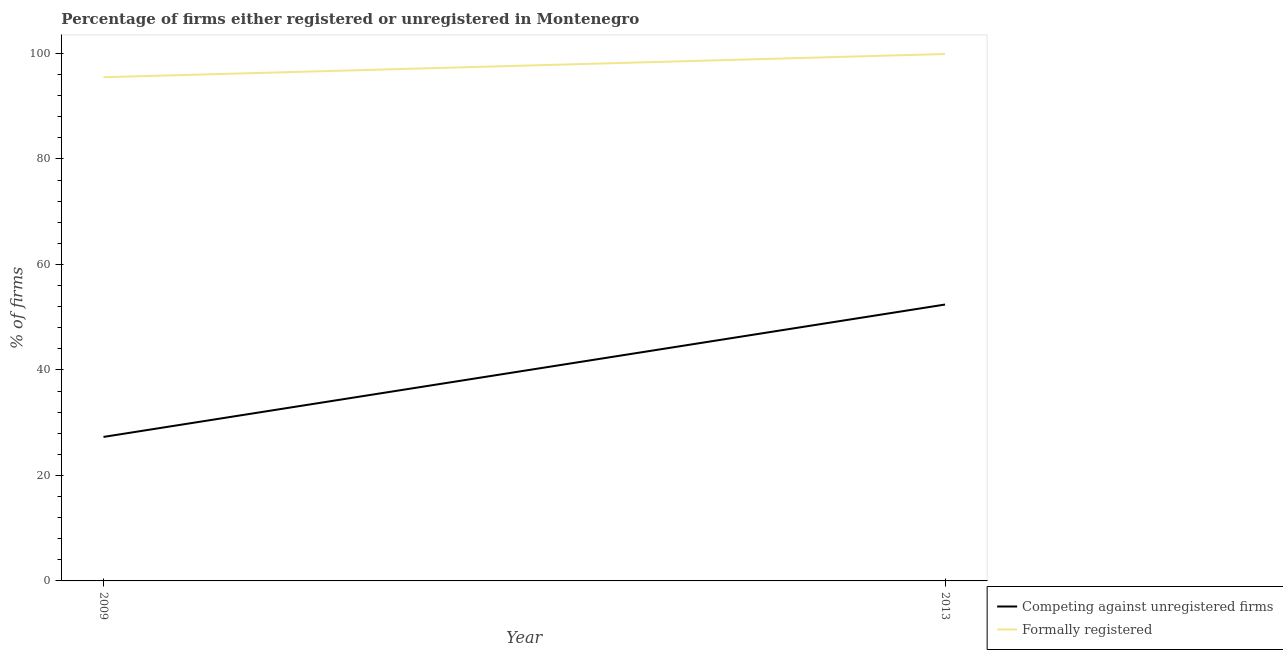How many different coloured lines are there?
Offer a very short reply. 2. What is the percentage of registered firms in 2009?
Offer a very short reply. 27.3. Across all years, what is the maximum percentage of formally registered firms?
Ensure brevity in your answer.  99.9. Across all years, what is the minimum percentage of registered firms?
Offer a terse response. 27.3. In which year was the percentage of registered firms maximum?
Provide a succinct answer. 2013. In which year was the percentage of registered firms minimum?
Your answer should be compact. 2009. What is the total percentage of registered firms in the graph?
Your answer should be very brief. 79.7. What is the difference between the percentage of registered firms in 2009 and that in 2013?
Keep it short and to the point. -25.1. What is the difference between the percentage of formally registered firms in 2009 and the percentage of registered firms in 2013?
Give a very brief answer. 43.1. What is the average percentage of formally registered firms per year?
Your answer should be compact. 97.7. In the year 2013, what is the difference between the percentage of formally registered firms and percentage of registered firms?
Offer a very short reply. 47.5. In how many years, is the percentage of formally registered firms greater than 20 %?
Ensure brevity in your answer.  2. What is the ratio of the percentage of formally registered firms in 2009 to that in 2013?
Ensure brevity in your answer.  0.96. Is the percentage of registered firms in 2009 less than that in 2013?
Provide a succinct answer. Yes. Does the percentage of formally registered firms monotonically increase over the years?
Keep it short and to the point. Yes. Is the percentage of formally registered firms strictly greater than the percentage of registered firms over the years?
Your response must be concise. Yes. Is the percentage of formally registered firms strictly less than the percentage of registered firms over the years?
Give a very brief answer. No. How many years are there in the graph?
Provide a short and direct response. 2. What is the difference between two consecutive major ticks on the Y-axis?
Give a very brief answer. 20. Are the values on the major ticks of Y-axis written in scientific E-notation?
Give a very brief answer. No. Does the graph contain grids?
Your answer should be very brief. No. Where does the legend appear in the graph?
Provide a succinct answer. Bottom right. How many legend labels are there?
Offer a very short reply. 2. How are the legend labels stacked?
Keep it short and to the point. Vertical. What is the title of the graph?
Provide a succinct answer. Percentage of firms either registered or unregistered in Montenegro. What is the label or title of the Y-axis?
Your response must be concise. % of firms. What is the % of firms in Competing against unregistered firms in 2009?
Provide a short and direct response. 27.3. What is the % of firms in Formally registered in 2009?
Offer a very short reply. 95.5. What is the % of firms of Competing against unregistered firms in 2013?
Make the answer very short. 52.4. What is the % of firms of Formally registered in 2013?
Offer a terse response. 99.9. Across all years, what is the maximum % of firms in Competing against unregistered firms?
Offer a very short reply. 52.4. Across all years, what is the maximum % of firms of Formally registered?
Offer a terse response. 99.9. Across all years, what is the minimum % of firms of Competing against unregistered firms?
Your answer should be compact. 27.3. Across all years, what is the minimum % of firms in Formally registered?
Give a very brief answer. 95.5. What is the total % of firms of Competing against unregistered firms in the graph?
Offer a very short reply. 79.7. What is the total % of firms of Formally registered in the graph?
Offer a terse response. 195.4. What is the difference between the % of firms of Competing against unregistered firms in 2009 and that in 2013?
Your answer should be very brief. -25.1. What is the difference between the % of firms of Formally registered in 2009 and that in 2013?
Give a very brief answer. -4.4. What is the difference between the % of firms of Competing against unregistered firms in 2009 and the % of firms of Formally registered in 2013?
Keep it short and to the point. -72.6. What is the average % of firms of Competing against unregistered firms per year?
Your answer should be very brief. 39.85. What is the average % of firms of Formally registered per year?
Keep it short and to the point. 97.7. In the year 2009, what is the difference between the % of firms of Competing against unregistered firms and % of firms of Formally registered?
Offer a very short reply. -68.2. In the year 2013, what is the difference between the % of firms of Competing against unregistered firms and % of firms of Formally registered?
Your answer should be very brief. -47.5. What is the ratio of the % of firms in Competing against unregistered firms in 2009 to that in 2013?
Make the answer very short. 0.52. What is the ratio of the % of firms of Formally registered in 2009 to that in 2013?
Your answer should be very brief. 0.96. What is the difference between the highest and the second highest % of firms of Competing against unregistered firms?
Your answer should be compact. 25.1. What is the difference between the highest and the lowest % of firms in Competing against unregistered firms?
Your response must be concise. 25.1. What is the difference between the highest and the lowest % of firms of Formally registered?
Provide a short and direct response. 4.4. 